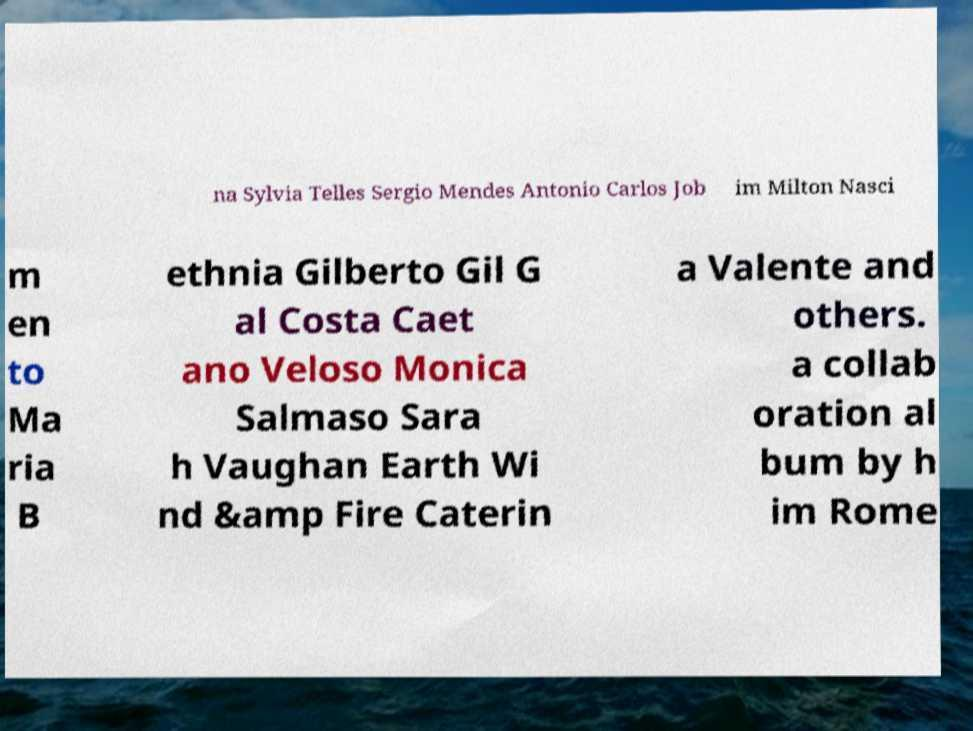Can you read and provide the text displayed in the image?This photo seems to have some interesting text. Can you extract and type it out for me? na Sylvia Telles Sergio Mendes Antonio Carlos Job im Milton Nasci m en to Ma ria B ethnia Gilberto Gil G al Costa Caet ano Veloso Monica Salmaso Sara h Vaughan Earth Wi nd &amp Fire Caterin a Valente and others. a collab oration al bum by h im Rome 